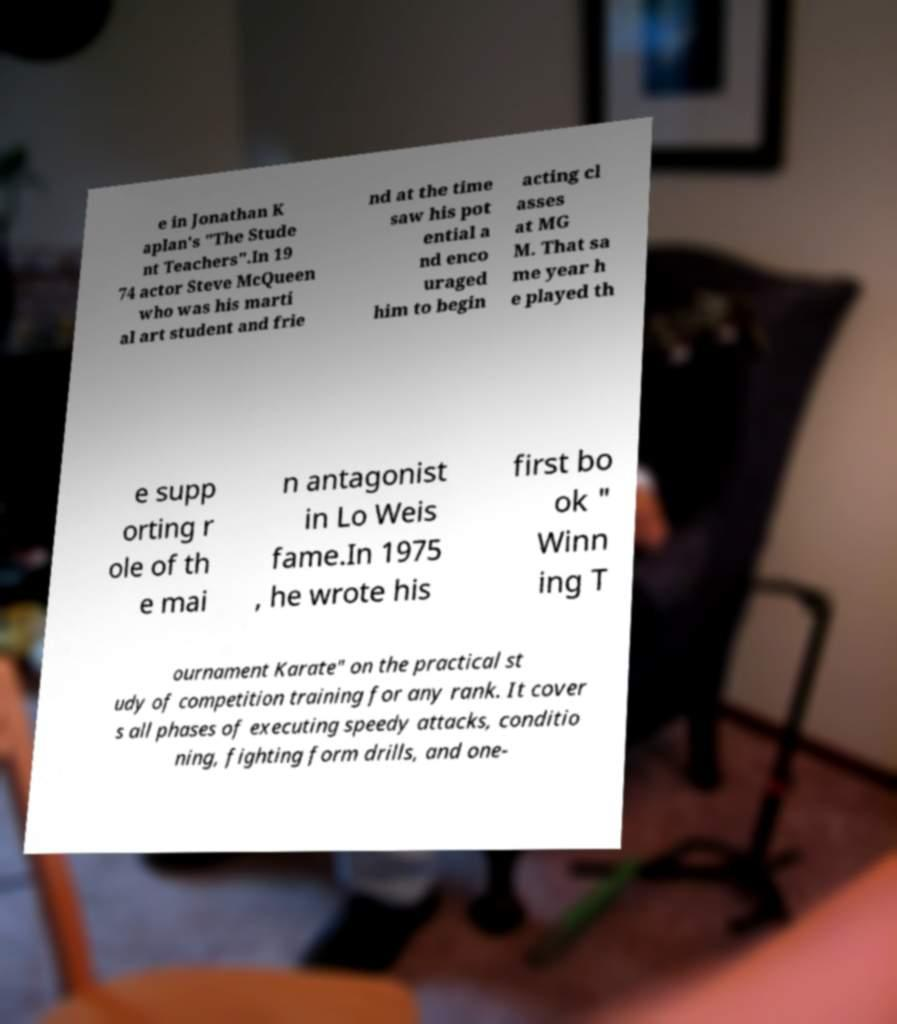Could you extract and type out the text from this image? e in Jonathan K aplan's "The Stude nt Teachers".In 19 74 actor Steve McQueen who was his marti al art student and frie nd at the time saw his pot ential a nd enco uraged him to begin acting cl asses at MG M. That sa me year h e played th e supp orting r ole of th e mai n antagonist in Lo Weis fame.In 1975 , he wrote his first bo ok " Winn ing T ournament Karate" on the practical st udy of competition training for any rank. It cover s all phases of executing speedy attacks, conditio ning, fighting form drills, and one- 